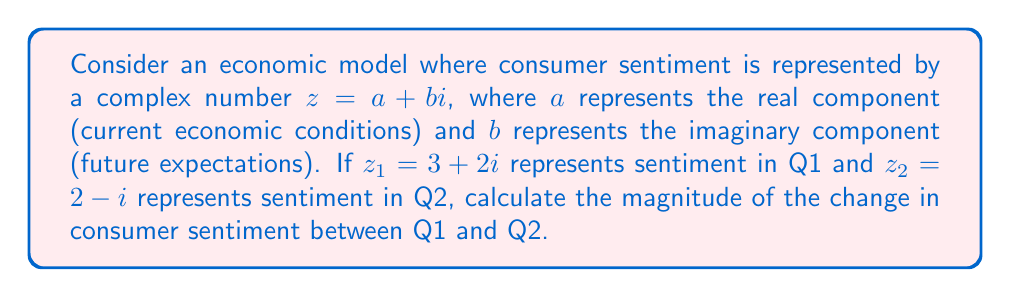Give your solution to this math problem. To solve this problem, we need to follow these steps:

1) The change in consumer sentiment is represented by the difference between $z_1$ and $z_2$:
   $$\Delta z = z_1 - z_2 = (3 + 2i) - (2 - i) = (3 - 2) + (2 - (-1))i = 1 + 3i$$

2) To find the magnitude of this change, we need to calculate the absolute value (or modulus) of the complex number $\Delta z$. For a complex number $a + bi$, the magnitude is given by:
   $$|a + bi| = \sqrt{a^2 + b^2}$$

3) In our case, $a = 1$ and $b = 3$. Let's substitute these values:
   $$|\Delta z| = |1 + 3i| = \sqrt{1^2 + 3^2}$$

4) Simplify:
   $$|\Delta z| = \sqrt{1 + 9} = \sqrt{10}$$

5) The square root of 10 cannot be simplified further, so this is our final answer.

This magnitude represents the overall change in consumer sentiment, considering both current conditions and future expectations.
Answer: $\sqrt{10}$ 